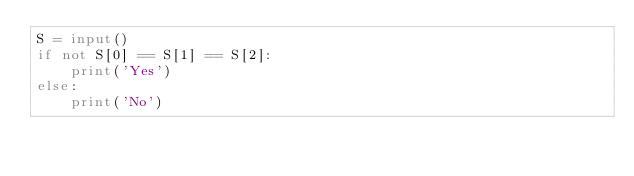Convert code to text. <code><loc_0><loc_0><loc_500><loc_500><_Python_>S = input()
if not S[0] == S[1] == S[2]:
    print('Yes')
else:
    print('No')
</code> 